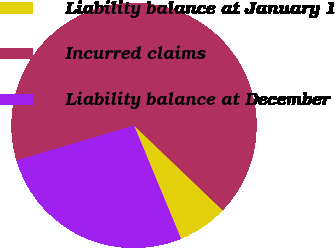Convert chart. <chart><loc_0><loc_0><loc_500><loc_500><pie_chart><fcel>Liability balance at January 1<fcel>Incurred claims<fcel>Liability balance at December<nl><fcel>6.59%<fcel>66.75%<fcel>26.66%<nl></chart> 